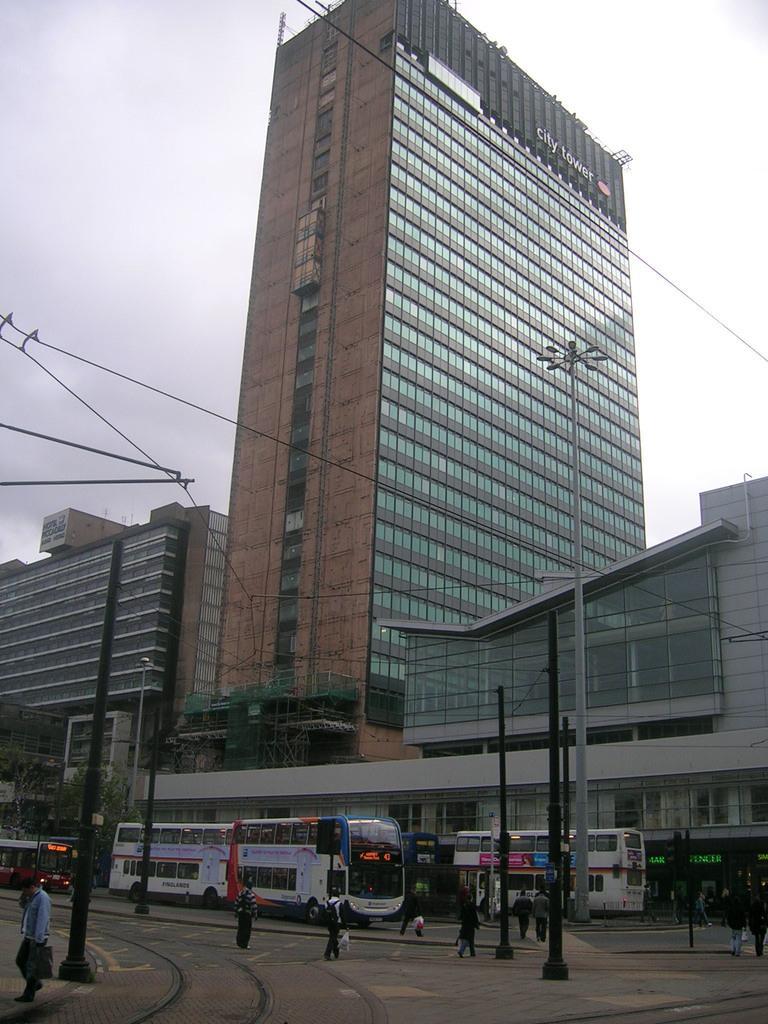Describe this image in one or two sentences. In this picture we can see buildings and skyscraper. In front of the building we can see many buses on the road, beside that we can see many peoples were walking and standing. On the right we can see the streetlights and black poles. In the bottom left corner there is a man who is wearing shirt, jeans, shoe and holding a bag and mobile phone. On the left we can see some trees. In the top left corner we can see sky and clouds. 